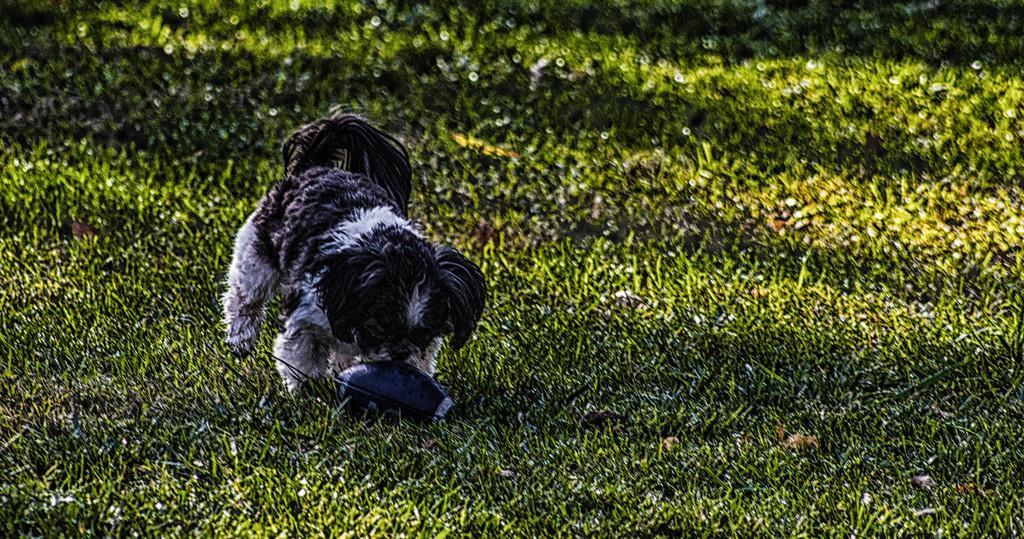Describe this image in one or two sentences. In the image there is a puppy standing on the grassland with a ball in front of it. 